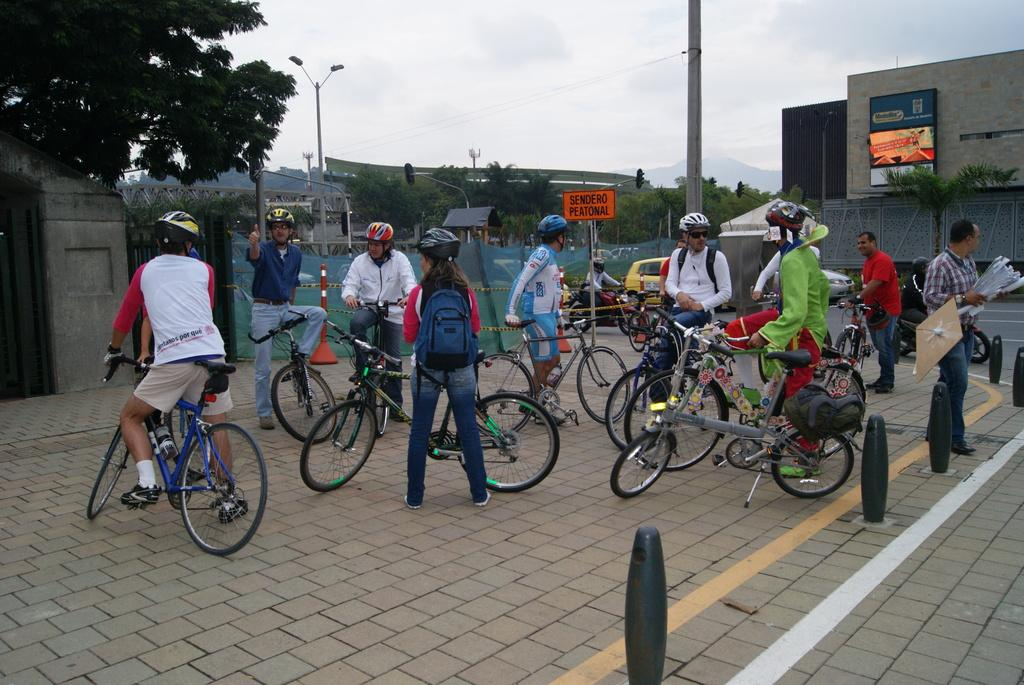What is the main activity taking place in the center of the image? There are many persons on cycles in the center of the image. What can be seen in the background of the image? There is a tree, buildings, a wall, nets, trees, poles, and the sky visible in the background of the image. Can you describe the sky in the background of the image? The sky is visible in the background of the image, and there are clouds present. What direction is the book facing in the image? There is no book present in the image. Can you describe the tiger's behavior in the image? There is no tiger present in the image. 